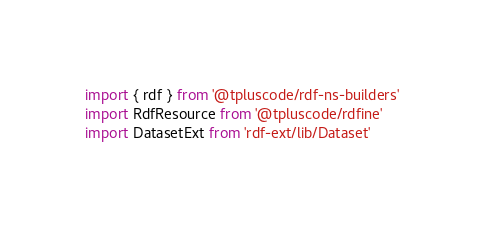Convert code to text. <code><loc_0><loc_0><loc_500><loc_500><_TypeScript_>import { rdf } from '@tpluscode/rdf-ns-builders'
import RdfResource from '@tpluscode/rdfine'
import DatasetExt from 'rdf-ext/lib/Dataset'</code> 